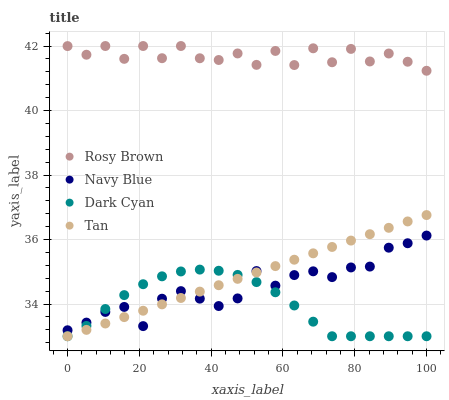Does Dark Cyan have the minimum area under the curve?
Answer yes or no. Yes. Does Rosy Brown have the maximum area under the curve?
Answer yes or no. Yes. Does Navy Blue have the minimum area under the curve?
Answer yes or no. No. Does Navy Blue have the maximum area under the curve?
Answer yes or no. No. Is Tan the smoothest?
Answer yes or no. Yes. Is Rosy Brown the roughest?
Answer yes or no. Yes. Is Navy Blue the smoothest?
Answer yes or no. No. Is Navy Blue the roughest?
Answer yes or no. No. Does Dark Cyan have the lowest value?
Answer yes or no. Yes. Does Navy Blue have the lowest value?
Answer yes or no. No. Does Rosy Brown have the highest value?
Answer yes or no. Yes. Does Navy Blue have the highest value?
Answer yes or no. No. Is Dark Cyan less than Rosy Brown?
Answer yes or no. Yes. Is Rosy Brown greater than Dark Cyan?
Answer yes or no. Yes. Does Dark Cyan intersect Tan?
Answer yes or no. Yes. Is Dark Cyan less than Tan?
Answer yes or no. No. Is Dark Cyan greater than Tan?
Answer yes or no. No. Does Dark Cyan intersect Rosy Brown?
Answer yes or no. No. 